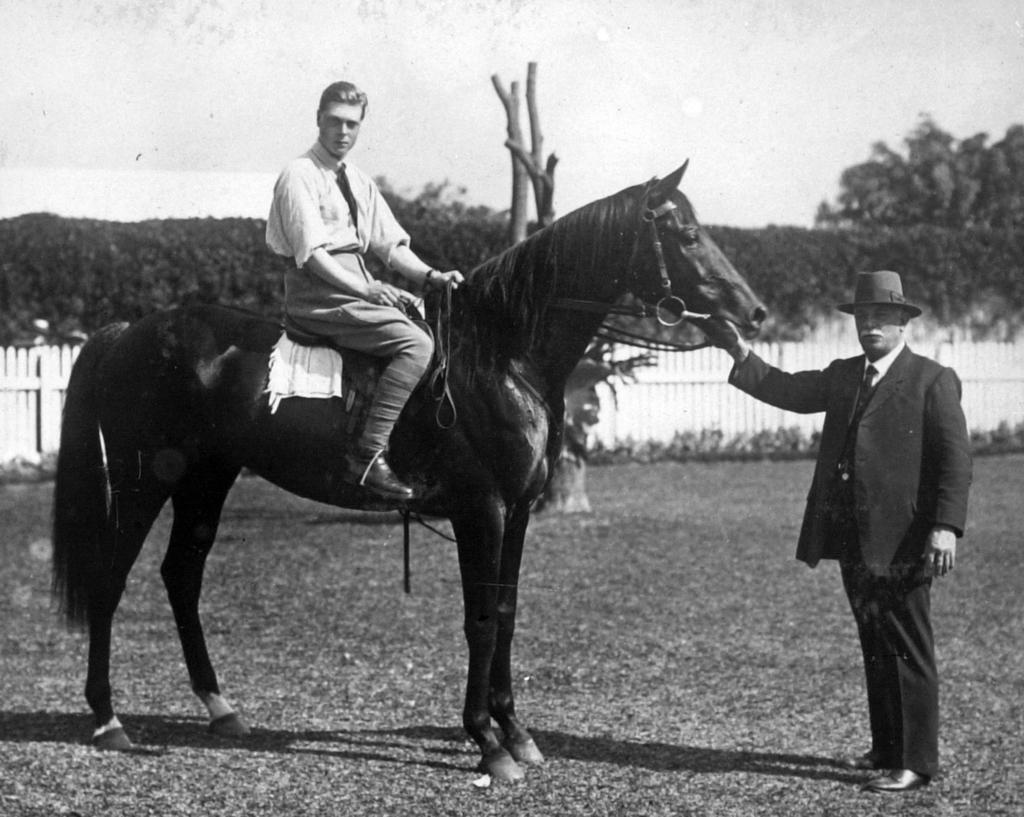How many people are in the image? There are two persons in the image. What are the people doing in the image? One person is seated on a horse, and another person is holding the horse. What can be seen in the background of the image? There is a fence and trees in the background of the image. What color is the nest in the image? There is no nest present in the image. What type of station is visible in the image? There is no station present in the image. 